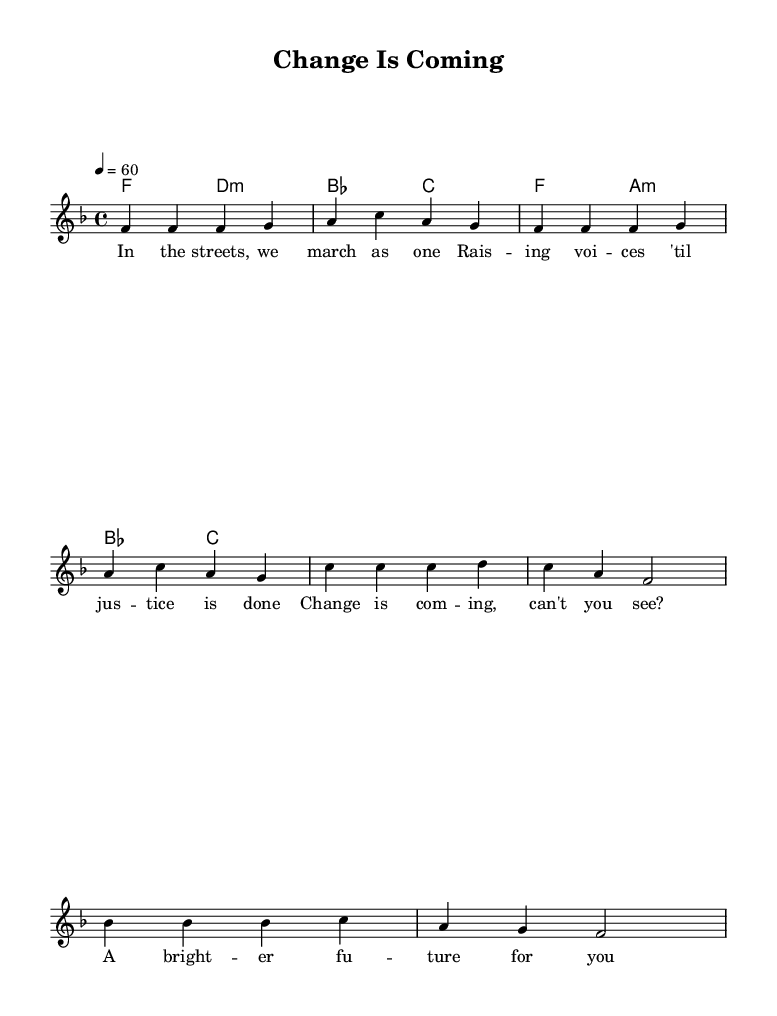What is the key signature of this music? The key signature is indicated by the absence of sharps or flats in the music sheet. It is F major, which is confirmed by the presence of the note F as the tonic in the melody and harmonies.
Answer: F major What is the time signature of this music? The time signature is typically found at the beginning of the music sheet. In this case, it is indicated as 4/4, which means there are four beats in each measure and the quarter note receives one beat.
Answer: 4/4 What is the tempo marking of this music? The tempo is given at the beginning of the music and is stated as "4 = 60," which indicates the number of beats per minute. This means a quarter note is played at a speed of 60 beats per minute.
Answer: 60 How many measures are in the verse? By counting the groups of notes and the vertical lines on the sheet music which indicate the end of each measure, it can be observed there are four measures in the verse section.
Answer: 4 What is the primary theme conveyed in the lyrics? Analyzing the provided lyrics suggests a message of unity and hope for social change, indicated by the phrases about marching together and striving for justice.
Answer: Unity and hope What type of chord progression is used in the chorus? The progression involves a mix of major and minor chords, which is characteristic of soul music, as it often conveys emotional depth, featuring changes from tonic to dominant chords.
Answer: Major and minor What lyrical technique is employed in the phrase "Change is coming"? This phrase employs repetition, a common lyrical technique in soul music, enhancing emotional appeal and emphasizing the message of hope for transformation.
Answer: Repetition 